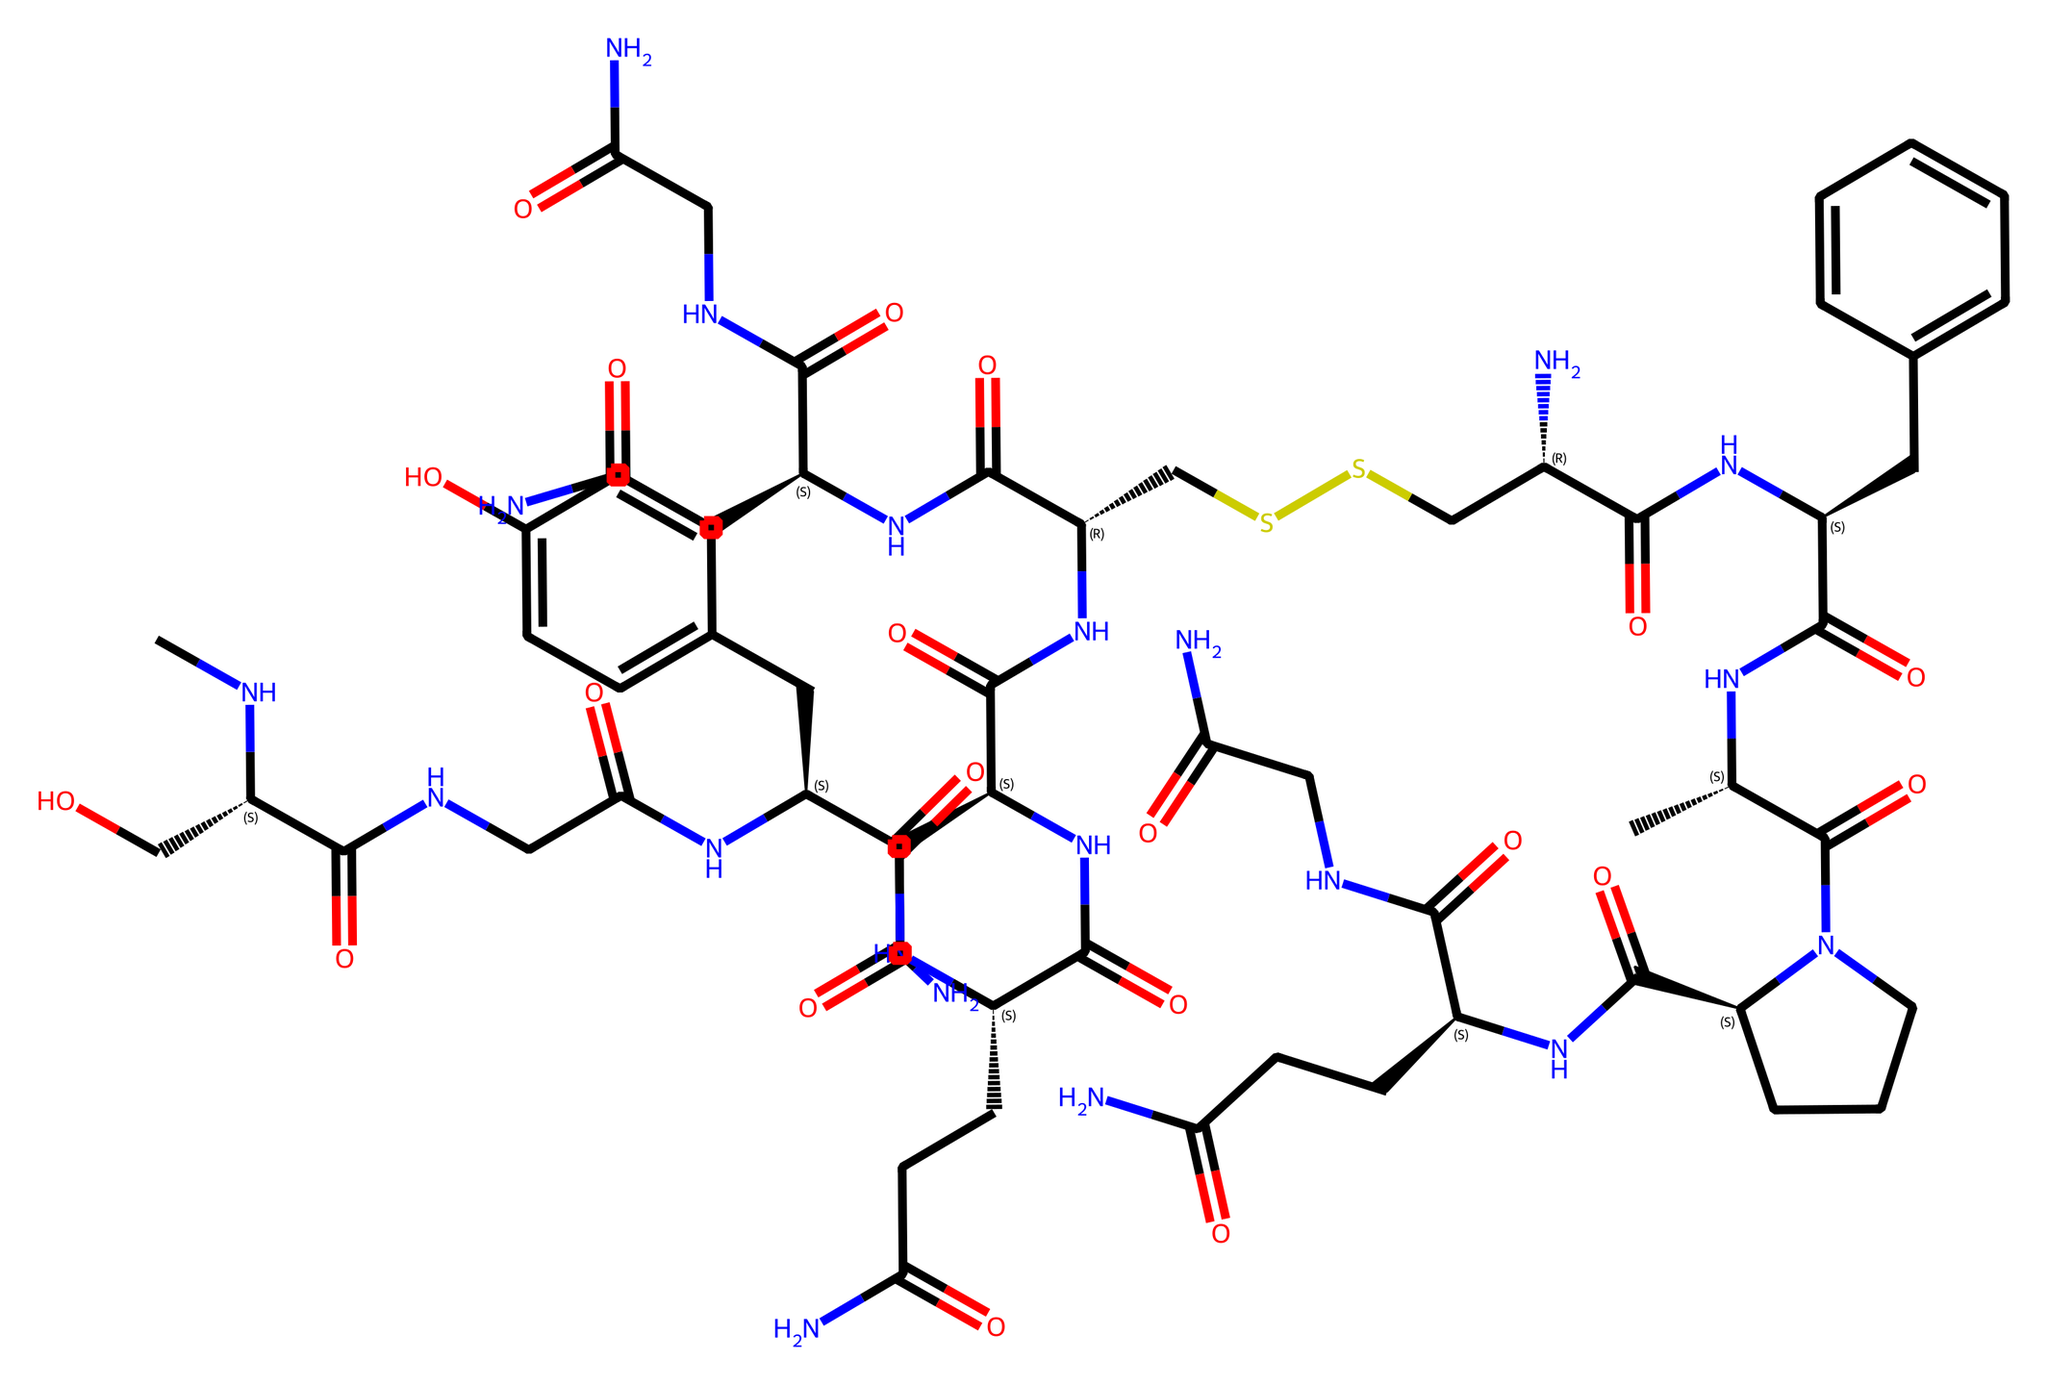How many amino acids are present in this molecule? To determine the number of amino acids, I need to look for the characteristic structure of amino acids, which includes an amino group, a carboxyl group, and a central carbon. By identifying and counting each unique amino acid structure visible within the chemical structure, I find there are 9 distinct amino acids.
Answer: 9 What is the molecular mass of the chemical represented by this SMILES? The molecular mass can be calculated by summing up the atomic masses of all the constituent atoms represented in the structure encoded by the SMILES notation. After calculating based on the individual atoms (Carbon, Hydrogen, Nitrogen, Oxygen, and Sulfur), the molecular mass is found to be approximately 1007.14 g/mol.
Answer: 1007.14 g/mol What functional groups are present in this hormone? To identify the functional groups, I observe specific arrangements of atoms within the molecule. Common hormone-related functional groups include amides (C(=O)N), thiols (RSH), and disulfides (RSSR). After analyzing, I identify that this hormone contains amide, thiol, and disulfide functional groups.
Answer: amide, thiol, disulfide Which part of the molecule is primarily responsible for bonding behavior? The regions that play a major role in bonding behavior typically involve the areas where amino acid side chains interact and the presence of disulfide bridges that stabilize the overall structure. In this case, the disulfide (CSSC) linkages are significant as they help stabilize the hormone, influencing its bonding behavior.
Answer: disulfide linkages What is the significance of the cyclic structure in oxytocin? Cyclic structures in hormones are important as they can influence stability and the way the hormone interacts with its receptor. In the case of oxytocin, the cyclic structure formed by the disulfide bridge contributes to its specific three-dimensional shape, which is essential for its biological activity.
Answer: stability and receptor interaction How does the presence of sulfur affect the function of this hormone? Sulfur in the form of disulfide linkages contributes to the molecule’s overall three-dimensional structure, effectively stabilizing it. This stability is crucial for maintaining the functional conformation necessary for oxytocin's activity in social bonding and reproductive behaviors.
Answer: stabilizes the structure 